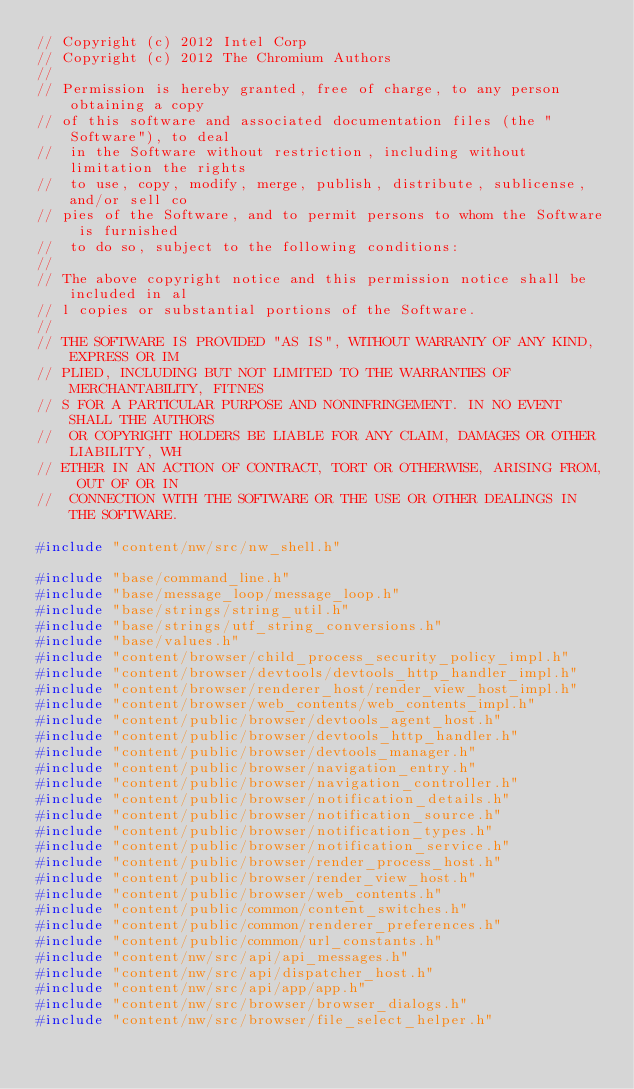<code> <loc_0><loc_0><loc_500><loc_500><_C++_>// Copyright (c) 2012 Intel Corp
// Copyright (c) 2012 The Chromium Authors
//
// Permission is hereby granted, free of charge, to any person obtaining a copy
// of this software and associated documentation files (the "Software"), to deal
//  in the Software without restriction, including without limitation the rights
//  to use, copy, modify, merge, publish, distribute, sublicense, and/or sell co
// pies of the Software, and to permit persons to whom the Software is furnished
//  to do so, subject to the following conditions:
//
// The above copyright notice and this permission notice shall be included in al
// l copies or substantial portions of the Software.
//
// THE SOFTWARE IS PROVIDED "AS IS", WITHOUT WARRANTY OF ANY KIND, EXPRESS OR IM
// PLIED, INCLUDING BUT NOT LIMITED TO THE WARRANTIES OF MERCHANTABILITY, FITNES
// S FOR A PARTICULAR PURPOSE AND NONINFRINGEMENT. IN NO EVENT SHALL THE AUTHORS
//  OR COPYRIGHT HOLDERS BE LIABLE FOR ANY CLAIM, DAMAGES OR OTHER LIABILITY, WH
// ETHER IN AN ACTION OF CONTRACT, TORT OR OTHERWISE, ARISING FROM, OUT OF OR IN
//  CONNECTION WITH THE SOFTWARE OR THE USE OR OTHER DEALINGS IN THE SOFTWARE.

#include "content/nw/src/nw_shell.h"

#include "base/command_line.h"
#include "base/message_loop/message_loop.h"
#include "base/strings/string_util.h"
#include "base/strings/utf_string_conversions.h"
#include "base/values.h"
#include "content/browser/child_process_security_policy_impl.h"
#include "content/browser/devtools/devtools_http_handler_impl.h"
#include "content/browser/renderer_host/render_view_host_impl.h"
#include "content/browser/web_contents/web_contents_impl.h"
#include "content/public/browser/devtools_agent_host.h"
#include "content/public/browser/devtools_http_handler.h"
#include "content/public/browser/devtools_manager.h"
#include "content/public/browser/navigation_entry.h"
#include "content/public/browser/navigation_controller.h"
#include "content/public/browser/notification_details.h"
#include "content/public/browser/notification_source.h"
#include "content/public/browser/notification_types.h"
#include "content/public/browser/notification_service.h"
#include "content/public/browser/render_process_host.h"
#include "content/public/browser/render_view_host.h"
#include "content/public/browser/web_contents.h"
#include "content/public/common/content_switches.h"
#include "content/public/common/renderer_preferences.h"
#include "content/public/common/url_constants.h"
#include "content/nw/src/api/api_messages.h"
#include "content/nw/src/api/dispatcher_host.h"
#include "content/nw/src/api/app/app.h"
#include "content/nw/src/browser/browser_dialogs.h"
#include "content/nw/src/browser/file_select_helper.h"</code> 